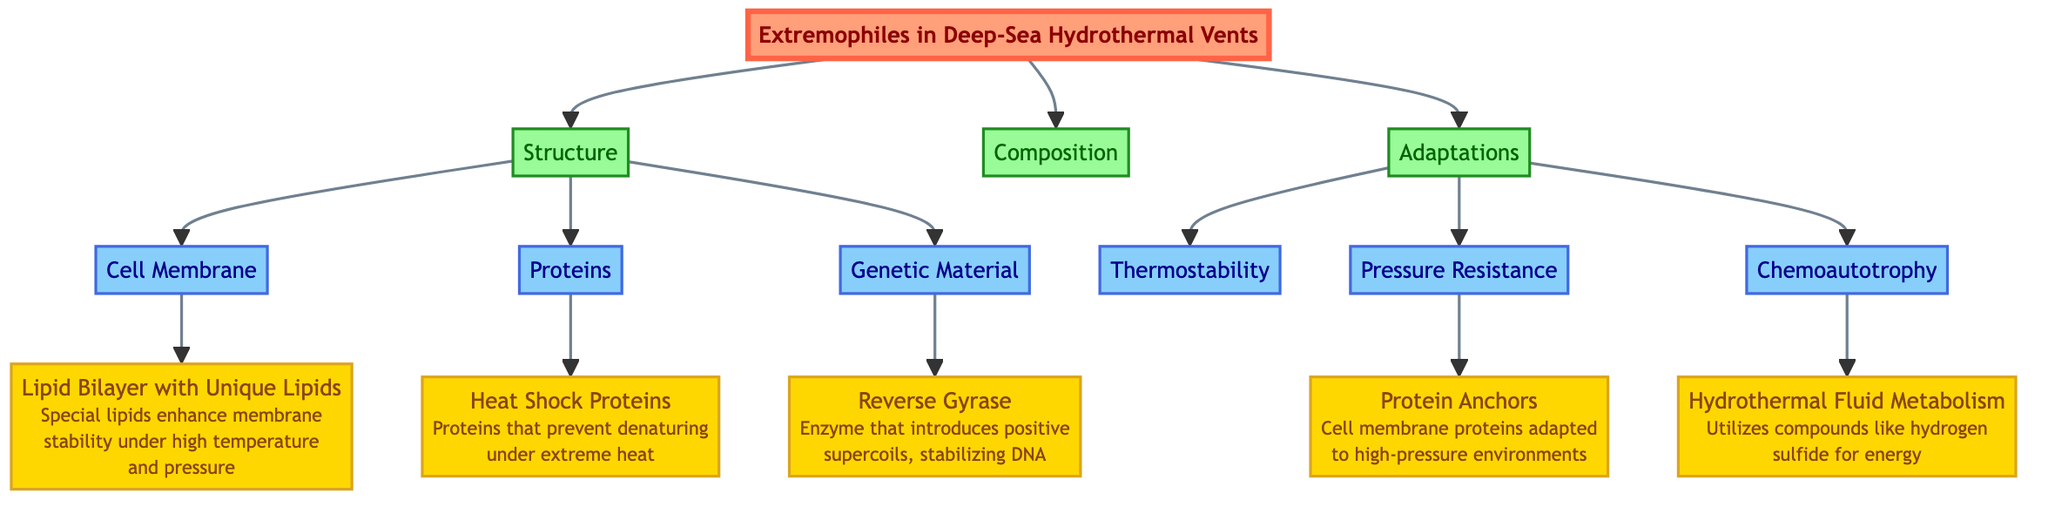What is the main topic of the diagram? The main topic of the diagram is indicated by the title node "Extremophiles in Deep-Sea Hydrothermal Vents," which serves as the primary subject of the flowchart.
Answer: Extremophiles in Deep-Sea Hydrothermal Vents How many main categories are there in this diagram? The diagram outlines three main categories branching from the extremophile node: "Structure," "Composition," and "Adaptations," totaling three.
Answer: 3 What type of lipids are mentioned in the context of cell membranes? The diagram specifies "Unique Lipids" as part of the lipid bilayer, indicating the specific adaptation for extremophiles.
Answer: Unique Lipids Which enzyme stabilizes the DNA in extremophiles? According to the diagram, "Reverse Gyrase" is the enzyme highlighted for its role in stabilizing DNA under extreme conditions.
Answer: Reverse Gyrase What adaptation helps extremophiles resist extreme pressure? The diagram points to "Protein Anchors" as the adaptation that allows these organisms to withstand high-pressure environments effectively.
Answer: Protein Anchors Which metabolic process is utilized by extremophiles for energy? The annotation shows that extremophiles utilize "Hydrothermal Fluid Metabolism" as a process for energy generation, particularly using hydrogen sulfide.
Answer: Hydrothermal Fluid Metabolism How does the structure of cell membranes contribute to stability? The lipid bilayer with unique lipids is specified as enhancing membrane stability under high temperature and pressure, showing how structure contributes to resilience.
Answer: Enhancing membrane stability What type of proteins are involved in preventing denaturing during extreme heat? The diagram describes "Heat Shock Proteins" as the specific proteins that prevent denaturing in high-temperature conditions, indicating their critical role in survival.
Answer: Heat Shock Proteins What is the relationship between "Chemoautotrophy" and "Hydrothermal Fluid Metabolism"? The diagram shows a direct connection where "Chemoautotrophy" leads to "Hydrothermal Fluid Metabolism," indicating that extremophiles utilize this metabolic strategy for energy.
Answer: Chemoautotrophy leads to Hydrothermal Fluid Metabolism 